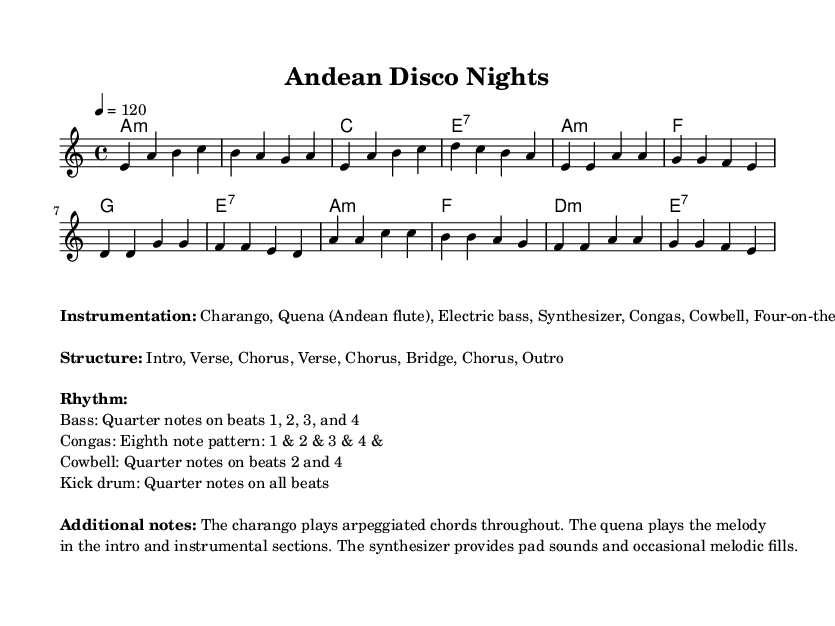What is the key signature of this music? The key signature, which determines the set of pitches used in the piece, is indicated at the beginning of the staff. The music has one flat, which corresponds to the key of A minor.
Answer: A minor What is the time signature of this music? The time signature is a crucial element that determines the rhythmic structure. It is found directly after the key signature. In this piece, the time signature is 4/4, indicating four beats per measure.
Answer: 4/4 What is the tempo marking for this piece? The tempo marking is indicated in beats per minute (bpm) at the beginning of the piece. Here, it states a tempo of 120 beats per minute, indicating how fast the music should be played.
Answer: 120 How many sections are there in the structure of the piece? The structure of the piece is outlined in the markup, listing the sections in order. There are eight distinct sections: Intro, Verse, Chorus, Verse, Chorus, Bridge, Chorus, and Outro.
Answer: 8 Which instrument plays the melody? To determine which instrument plays the melody, one can look at the instrument names in the instrumentation section of the score. The quena, an Andean flute, is noted as the instrument that plays the melody in the intro and instrumental sections.
Answer: Quena What type of rhythmic pattern do the congas play? The rhythmic pattern for the congas can be found in the description under the rhythm section in the markup. It specifies an eighth note pattern played as "1 & 2 & 3 & 4 &," indicating a syncopated feel typical in disco music.
Answer: Eighth note pattern 